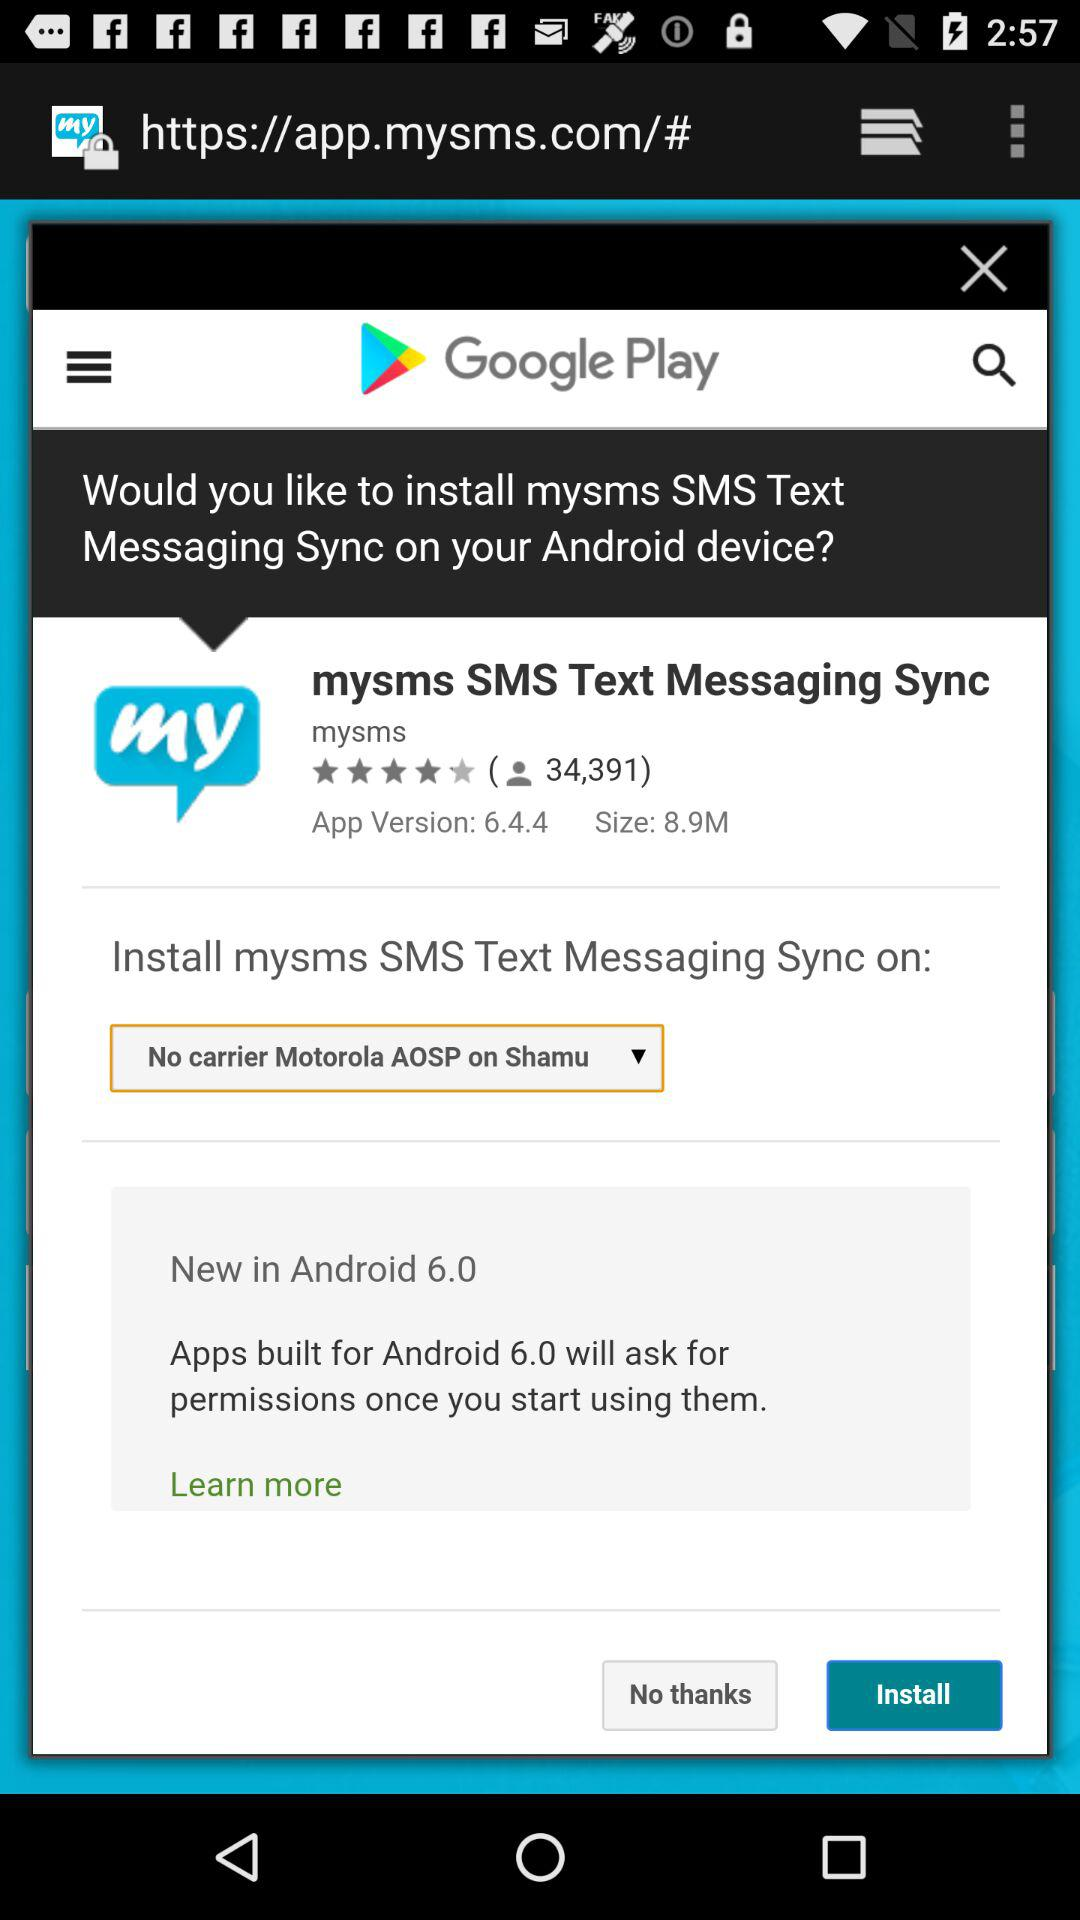How many people used this app?
When the provided information is insufficient, respond with <no answer>. <no answer> 